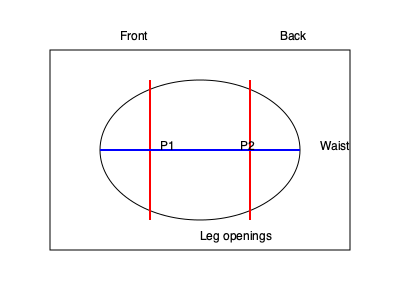Based on the anatomical diagram of a diaper cover design, which shows pressure points P1 and P2, calculate the optimal elastic tension $T$ (in N/m) for the leg openings if the desired pressure at these points is 2 kPa and the elastic width is 1 cm. Assume the leg circumference at these points is 25 cm. How would this tension affect the overall ergonomics of the diaper cover? To solve this problem, we'll follow these steps:

1. Understand the given information:
   - Desired pressure (P) = 2 kPa = 2000 Pa
   - Elastic width (w) = 1 cm = 0.01 m
   - Leg circumference (C) = 25 cm = 0.25 m

2. Use the pressure formula: $P = \frac{F}{A}$
   Where F is the force and A is the area.

3. Calculate the area (A) of elastic contact:
   $A = w * C = 0.01 \text{ m} * 0.25 \text{ m} = 0.0025 \text{ m}^2$

4. Calculate the force (F) needed to create the desired pressure:
   $F = P * A = 2000 \text{ Pa} * 0.0025 \text{ m}^2 = 5 \text{ N}$

5. Calculate the tension (T) in the elastic:
   $T = \frac{F}{C} = \frac{5 \text{ N}}{0.25 \text{ m}} = 20 \text{ N/m}$

6. Ergonomic considerations:
   - The calculated tension of 20 N/m provides the desired pressure at points P1 and P2, ensuring a snug fit around the legs to prevent leaks.
   - This moderate tension allows for comfort and movement while maintaining the diaper cover's functionality.
   - Even pressure distribution along the leg openings reduces the risk of skin irritation or marks.
   - The elastic tension should be balanced with the overall design to avoid restricting blood flow or causing discomfort during extended wear.
   - Consider using wider elastic or distributing the tension over a larger area to further improve comfort and reduce pressure points.
Answer: 20 N/m; balanced fit, leak prevention, comfort, and reduced skin irritation. 